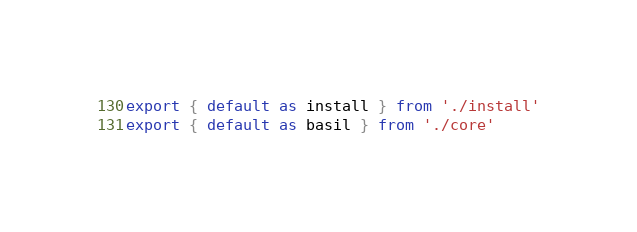Convert code to text. <code><loc_0><loc_0><loc_500><loc_500><_JavaScript_>export { default as install } from './install'
export { default as basil } from './core'
</code> 